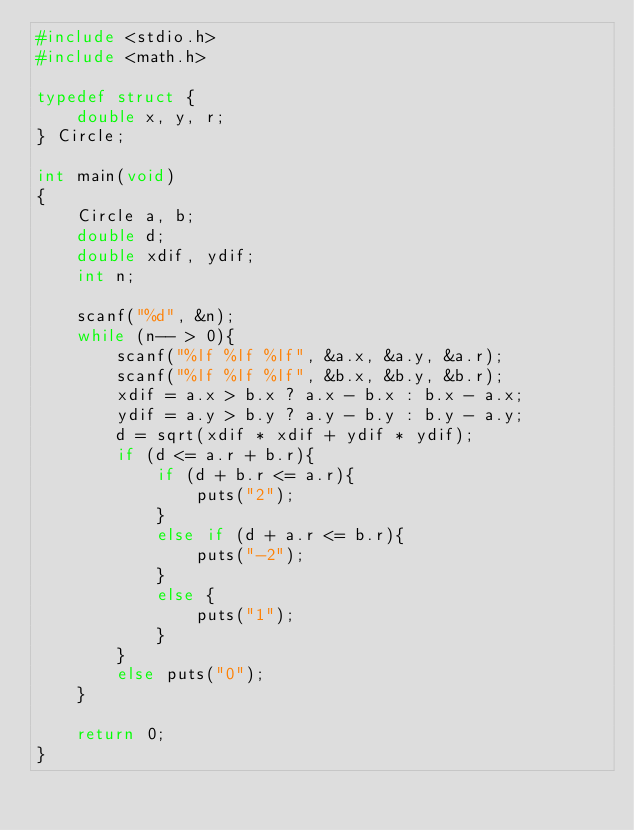<code> <loc_0><loc_0><loc_500><loc_500><_C_>#include <stdio.h>
#include <math.h>

typedef struct {
	double x, y, r;
} Circle;

int main(void)
{
	Circle a, b;
	double d;
	double xdif, ydif;
	int n;
	
	scanf("%d", &n);
	while (n-- > 0){
		scanf("%lf %lf %lf", &a.x, &a.y, &a.r);
		scanf("%lf %lf %lf", &b.x, &b.y, &b.r);
		xdif = a.x > b.x ? a.x - b.x : b.x - a.x;
		ydif = a.y > b.y ? a.y - b.y : b.y - a.y;
		d = sqrt(xdif * xdif + ydif * ydif);
		if (d <= a.r + b.r){
			if (d + b.r <= a.r){
				puts("2");
			}
			else if (d + a.r <= b.r){
				puts("-2");
			}
			else {
				puts("1");
			}
		}
		else puts("0");
	}
	
	return 0;
}</code> 